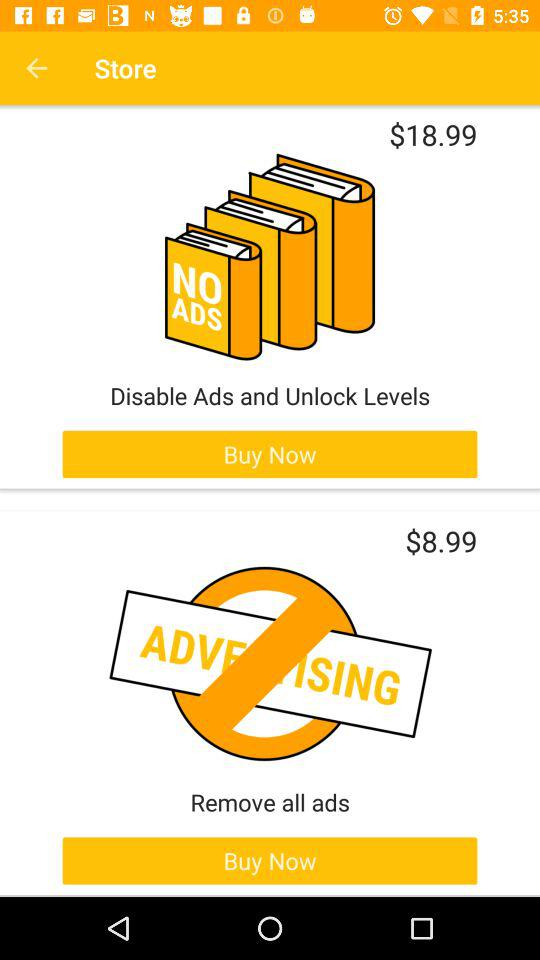What is the price of removing all ads? The price is $8.99. 